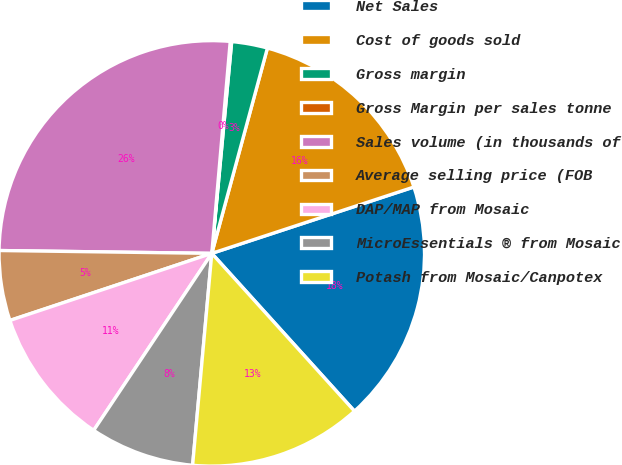Convert chart to OTSL. <chart><loc_0><loc_0><loc_500><loc_500><pie_chart><fcel>Net Sales<fcel>Cost of goods sold<fcel>Gross margin<fcel>Gross Margin per sales tonne<fcel>Sales volume (in thousands of<fcel>Average selling price (FOB<fcel>DAP/MAP from Mosaic<fcel>MicroEssentials ® from Mosaic<fcel>Potash from Mosaic/Canpotex<nl><fcel>18.35%<fcel>15.74%<fcel>2.72%<fcel>0.11%<fcel>26.17%<fcel>5.32%<fcel>10.53%<fcel>7.93%<fcel>13.14%<nl></chart> 